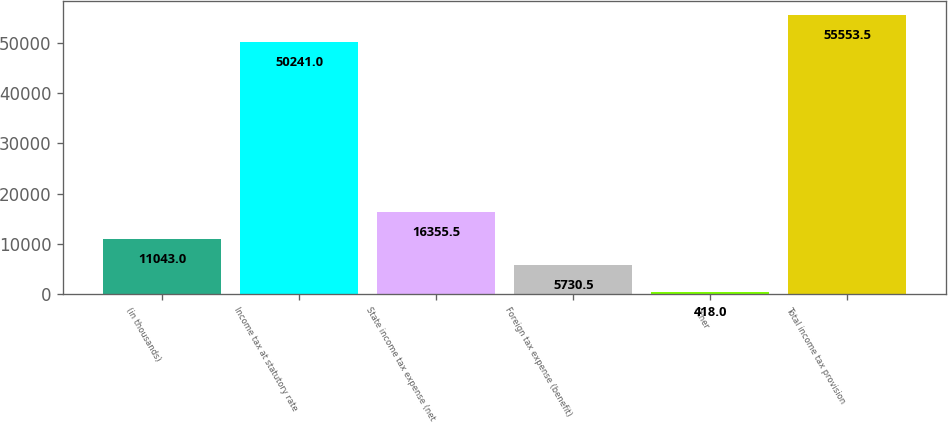Convert chart to OTSL. <chart><loc_0><loc_0><loc_500><loc_500><bar_chart><fcel>(in thousands)<fcel>Income tax at statutory rate<fcel>State income tax expense (net<fcel>Foreign tax expense (benefit)<fcel>Other<fcel>Total income tax provision<nl><fcel>11043<fcel>50241<fcel>16355.5<fcel>5730.5<fcel>418<fcel>55553.5<nl></chart> 